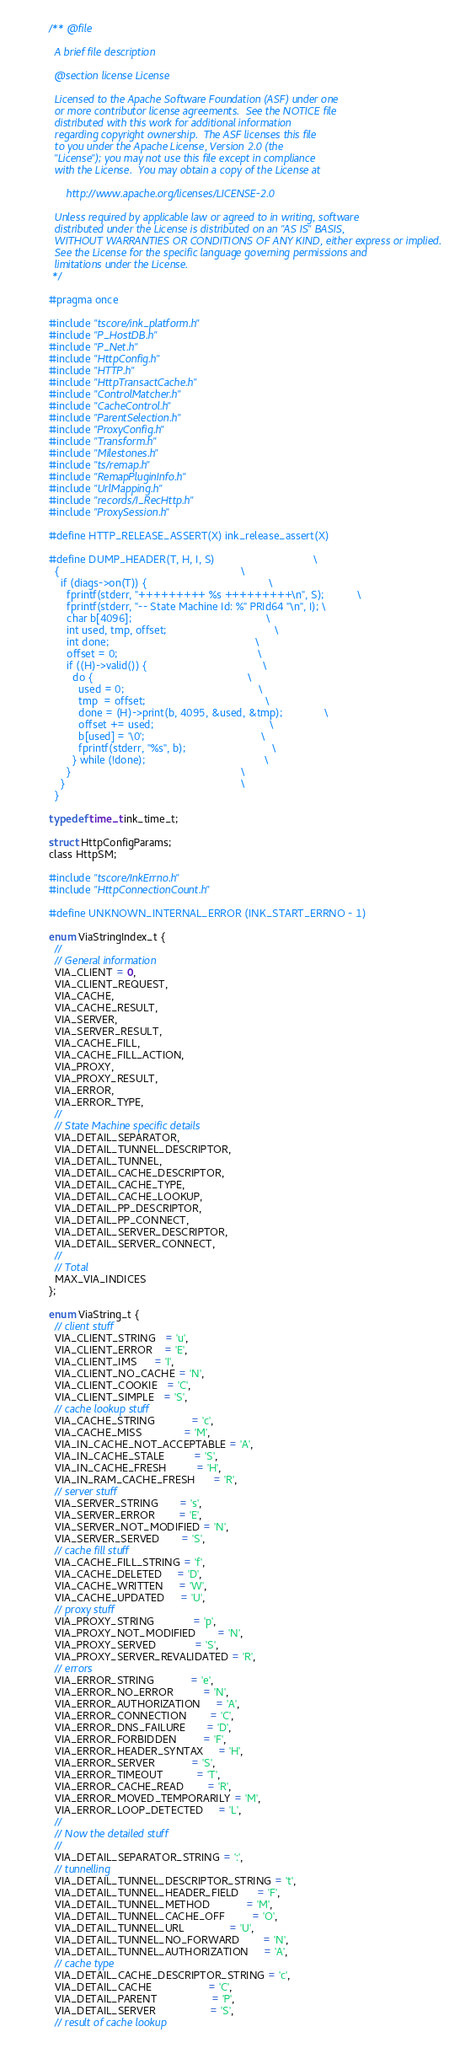<code> <loc_0><loc_0><loc_500><loc_500><_C_>/** @file

  A brief file description

  @section license License

  Licensed to the Apache Software Foundation (ASF) under one
  or more contributor license agreements.  See the NOTICE file
  distributed with this work for additional information
  regarding copyright ownership.  The ASF licenses this file
  to you under the Apache License, Version 2.0 (the
  "License"); you may not use this file except in compliance
  with the License.  You may obtain a copy of the License at

      http://www.apache.org/licenses/LICENSE-2.0

  Unless required by applicable law or agreed to in writing, software
  distributed under the License is distributed on an "AS IS" BASIS,
  WITHOUT WARRANTIES OR CONDITIONS OF ANY KIND, either express or implied.
  See the License for the specific language governing permissions and
  limitations under the License.
 */

#pragma once

#include "tscore/ink_platform.h"
#include "P_HostDB.h"
#include "P_Net.h"
#include "HttpConfig.h"
#include "HTTP.h"
#include "HttpTransactCache.h"
#include "ControlMatcher.h"
#include "CacheControl.h"
#include "ParentSelection.h"
#include "ProxyConfig.h"
#include "Transform.h"
#include "Milestones.h"
#include "ts/remap.h"
#include "RemapPluginInfo.h"
#include "UrlMapping.h"
#include "records/I_RecHttp.h"
#include "ProxySession.h"

#define HTTP_RELEASE_ASSERT(X) ink_release_assert(X)

#define DUMP_HEADER(T, H, I, S)                                 \
  {                                                             \
    if (diags->on(T)) {                                         \
      fprintf(stderr, "+++++++++ %s +++++++++\n", S);           \
      fprintf(stderr, "-- State Machine Id: %" PRId64 "\n", I); \
      char b[4096];                                             \
      int used, tmp, offset;                                    \
      int done;                                                 \
      offset = 0;                                               \
      if ((H)->valid()) {                                       \
        do {                                                    \
          used = 0;                                             \
          tmp  = offset;                                        \
          done = (H)->print(b, 4095, &used, &tmp);              \
          offset += used;                                       \
          b[used] = '\0';                                       \
          fprintf(stderr, "%s", b);                             \
        } while (!done);                                        \
      }                                                         \
    }                                                           \
  }

typedef time_t ink_time_t;

struct HttpConfigParams;
class HttpSM;

#include "tscore/InkErrno.h"
#include "HttpConnectionCount.h"

#define UNKNOWN_INTERNAL_ERROR (INK_START_ERRNO - 1)

enum ViaStringIndex_t {
  //
  // General information
  VIA_CLIENT = 0,
  VIA_CLIENT_REQUEST,
  VIA_CACHE,
  VIA_CACHE_RESULT,
  VIA_SERVER,
  VIA_SERVER_RESULT,
  VIA_CACHE_FILL,
  VIA_CACHE_FILL_ACTION,
  VIA_PROXY,
  VIA_PROXY_RESULT,
  VIA_ERROR,
  VIA_ERROR_TYPE,
  //
  // State Machine specific details
  VIA_DETAIL_SEPARATOR,
  VIA_DETAIL_TUNNEL_DESCRIPTOR,
  VIA_DETAIL_TUNNEL,
  VIA_DETAIL_CACHE_DESCRIPTOR,
  VIA_DETAIL_CACHE_TYPE,
  VIA_DETAIL_CACHE_LOOKUP,
  VIA_DETAIL_PP_DESCRIPTOR,
  VIA_DETAIL_PP_CONNECT,
  VIA_DETAIL_SERVER_DESCRIPTOR,
  VIA_DETAIL_SERVER_CONNECT,
  //
  // Total
  MAX_VIA_INDICES
};

enum ViaString_t {
  // client stuff
  VIA_CLIENT_STRING   = 'u',
  VIA_CLIENT_ERROR    = 'E',
  VIA_CLIENT_IMS      = 'I',
  VIA_CLIENT_NO_CACHE = 'N',
  VIA_CLIENT_COOKIE   = 'C',
  VIA_CLIENT_SIMPLE   = 'S',
  // cache lookup stuff
  VIA_CACHE_STRING            = 'c',
  VIA_CACHE_MISS              = 'M',
  VIA_IN_CACHE_NOT_ACCEPTABLE = 'A',
  VIA_IN_CACHE_STALE          = 'S',
  VIA_IN_CACHE_FRESH          = 'H',
  VIA_IN_RAM_CACHE_FRESH      = 'R',
  // server stuff
  VIA_SERVER_STRING       = 's',
  VIA_SERVER_ERROR        = 'E',
  VIA_SERVER_NOT_MODIFIED = 'N',
  VIA_SERVER_SERVED       = 'S',
  // cache fill stuff
  VIA_CACHE_FILL_STRING = 'f',
  VIA_CACHE_DELETED     = 'D',
  VIA_CACHE_WRITTEN     = 'W',
  VIA_CACHE_UPDATED     = 'U',
  // proxy stuff
  VIA_PROXY_STRING             = 'p',
  VIA_PROXY_NOT_MODIFIED       = 'N',
  VIA_PROXY_SERVED             = 'S',
  VIA_PROXY_SERVER_REVALIDATED = 'R',
  // errors
  VIA_ERROR_STRING            = 'e',
  VIA_ERROR_NO_ERROR          = 'N',
  VIA_ERROR_AUTHORIZATION     = 'A',
  VIA_ERROR_CONNECTION        = 'C',
  VIA_ERROR_DNS_FAILURE       = 'D',
  VIA_ERROR_FORBIDDEN         = 'F',
  VIA_ERROR_HEADER_SYNTAX     = 'H',
  VIA_ERROR_SERVER            = 'S',
  VIA_ERROR_TIMEOUT           = 'T',
  VIA_ERROR_CACHE_READ        = 'R',
  VIA_ERROR_MOVED_TEMPORARILY = 'M',
  VIA_ERROR_LOOP_DETECTED     = 'L',
  //
  // Now the detailed stuff
  //
  VIA_DETAIL_SEPARATOR_STRING = ':',
  // tunnelling
  VIA_DETAIL_TUNNEL_DESCRIPTOR_STRING = 't',
  VIA_DETAIL_TUNNEL_HEADER_FIELD      = 'F',
  VIA_DETAIL_TUNNEL_METHOD            = 'M',
  VIA_DETAIL_TUNNEL_CACHE_OFF         = 'O',
  VIA_DETAIL_TUNNEL_URL               = 'U',
  VIA_DETAIL_TUNNEL_NO_FORWARD        = 'N',
  VIA_DETAIL_TUNNEL_AUTHORIZATION     = 'A',
  // cache type
  VIA_DETAIL_CACHE_DESCRIPTOR_STRING = 'c',
  VIA_DETAIL_CACHE                   = 'C',
  VIA_DETAIL_PARENT                  = 'P',
  VIA_DETAIL_SERVER                  = 'S',
  // result of cache lookup</code> 